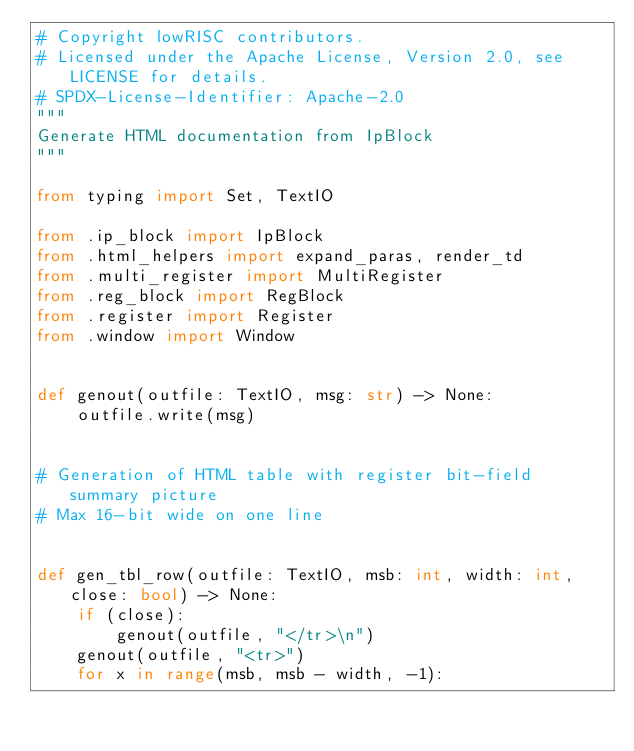<code> <loc_0><loc_0><loc_500><loc_500><_Python_># Copyright lowRISC contributors.
# Licensed under the Apache License, Version 2.0, see LICENSE for details.
# SPDX-License-Identifier: Apache-2.0
"""
Generate HTML documentation from IpBlock
"""

from typing import Set, TextIO

from .ip_block import IpBlock
from .html_helpers import expand_paras, render_td
from .multi_register import MultiRegister
from .reg_block import RegBlock
from .register import Register
from .window import Window


def genout(outfile: TextIO, msg: str) -> None:
    outfile.write(msg)


# Generation of HTML table with register bit-field summary picture
# Max 16-bit wide on one line


def gen_tbl_row(outfile: TextIO, msb: int, width: int, close: bool) -> None:
    if (close):
        genout(outfile, "</tr>\n")
    genout(outfile, "<tr>")
    for x in range(msb, msb - width, -1):</code> 